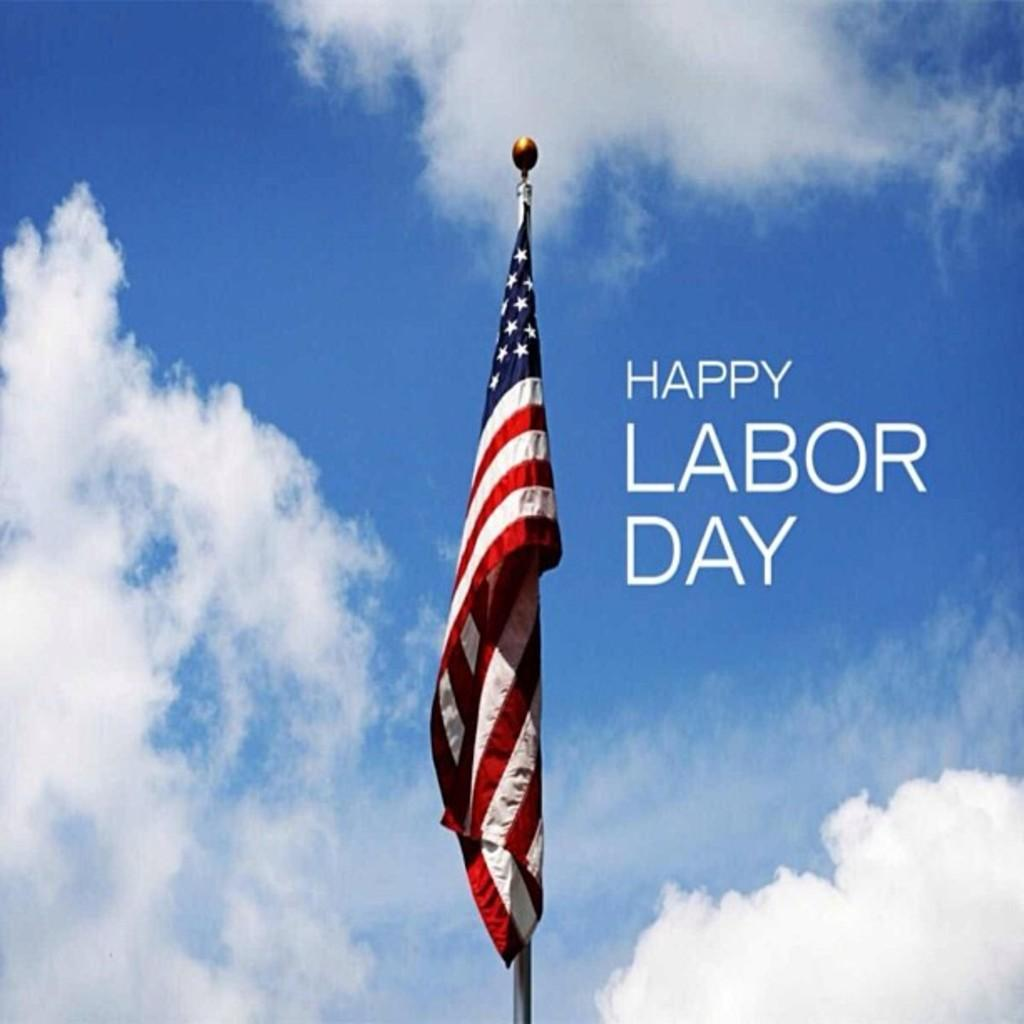What is on the pole in the image? There is an American flag on a pole in the image. What message is written in the background? The phrase "happy labour day" is written in the background. What is the color of the sky in the image? The sky is blue in the background. What can be seen in the sky besides the blue color? Clouds are visible in the sky. Is there a receipt visible in the image? No, there is no receipt present in the image. What season is depicted in the image based on the presence of snow or winter clothing? The facts provided do not mention snow or winter clothing, so it cannot be determined if the image depicts a specific season. 